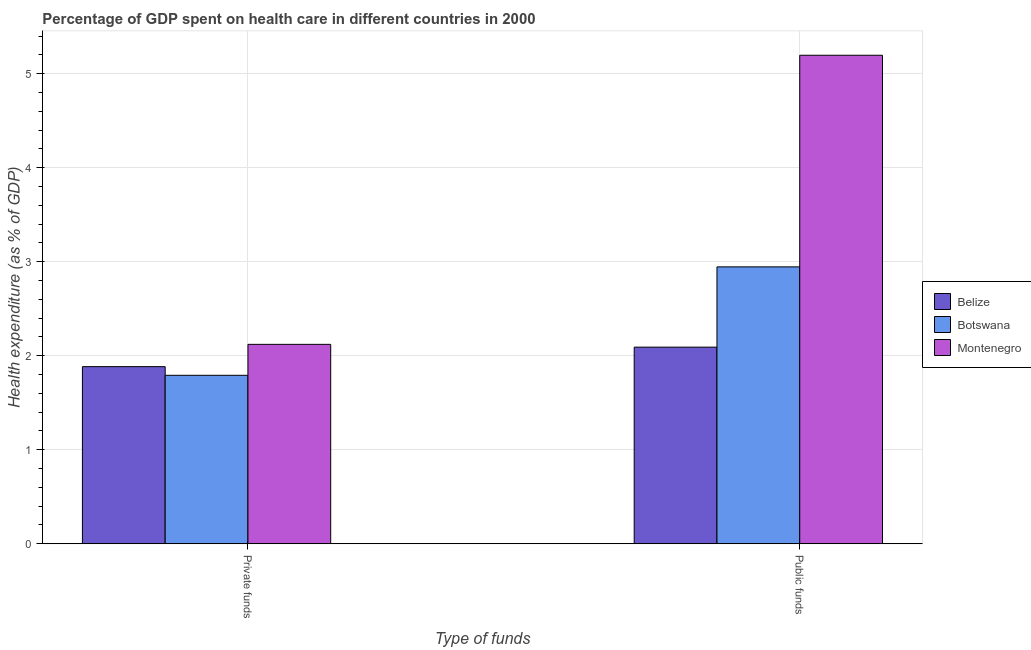How many groups of bars are there?
Provide a succinct answer. 2. Are the number of bars per tick equal to the number of legend labels?
Your answer should be compact. Yes. What is the label of the 1st group of bars from the left?
Make the answer very short. Private funds. What is the amount of private funds spent in healthcare in Botswana?
Make the answer very short. 1.79. Across all countries, what is the maximum amount of public funds spent in healthcare?
Offer a terse response. 5.2. Across all countries, what is the minimum amount of public funds spent in healthcare?
Make the answer very short. 2.09. In which country was the amount of public funds spent in healthcare maximum?
Your answer should be compact. Montenegro. In which country was the amount of private funds spent in healthcare minimum?
Provide a short and direct response. Botswana. What is the total amount of private funds spent in healthcare in the graph?
Provide a succinct answer. 5.8. What is the difference between the amount of public funds spent in healthcare in Montenegro and that in Botswana?
Offer a terse response. 2.25. What is the difference between the amount of private funds spent in healthcare in Botswana and the amount of public funds spent in healthcare in Montenegro?
Offer a very short reply. -3.4. What is the average amount of private funds spent in healthcare per country?
Keep it short and to the point. 1.93. What is the difference between the amount of public funds spent in healthcare and amount of private funds spent in healthcare in Montenegro?
Keep it short and to the point. 3.08. What is the ratio of the amount of public funds spent in healthcare in Belize to that in Montenegro?
Your response must be concise. 0.4. In how many countries, is the amount of public funds spent in healthcare greater than the average amount of public funds spent in healthcare taken over all countries?
Offer a terse response. 1. What does the 2nd bar from the left in Public funds represents?
Provide a short and direct response. Botswana. What does the 2nd bar from the right in Public funds represents?
Keep it short and to the point. Botswana. How many countries are there in the graph?
Offer a very short reply. 3. What is the difference between two consecutive major ticks on the Y-axis?
Make the answer very short. 1. Are the values on the major ticks of Y-axis written in scientific E-notation?
Give a very brief answer. No. What is the title of the graph?
Keep it short and to the point. Percentage of GDP spent on health care in different countries in 2000. What is the label or title of the X-axis?
Give a very brief answer. Type of funds. What is the label or title of the Y-axis?
Your answer should be very brief. Health expenditure (as % of GDP). What is the Health expenditure (as % of GDP) in Belize in Private funds?
Give a very brief answer. 1.88. What is the Health expenditure (as % of GDP) of Botswana in Private funds?
Keep it short and to the point. 1.79. What is the Health expenditure (as % of GDP) of Montenegro in Private funds?
Offer a terse response. 2.12. What is the Health expenditure (as % of GDP) of Belize in Public funds?
Give a very brief answer. 2.09. What is the Health expenditure (as % of GDP) of Botswana in Public funds?
Provide a short and direct response. 2.95. What is the Health expenditure (as % of GDP) of Montenegro in Public funds?
Your answer should be very brief. 5.2. Across all Type of funds, what is the maximum Health expenditure (as % of GDP) in Belize?
Your response must be concise. 2.09. Across all Type of funds, what is the maximum Health expenditure (as % of GDP) in Botswana?
Your answer should be compact. 2.95. Across all Type of funds, what is the maximum Health expenditure (as % of GDP) of Montenegro?
Offer a very short reply. 5.2. Across all Type of funds, what is the minimum Health expenditure (as % of GDP) in Belize?
Provide a succinct answer. 1.88. Across all Type of funds, what is the minimum Health expenditure (as % of GDP) in Botswana?
Your response must be concise. 1.79. Across all Type of funds, what is the minimum Health expenditure (as % of GDP) of Montenegro?
Make the answer very short. 2.12. What is the total Health expenditure (as % of GDP) of Belize in the graph?
Your response must be concise. 3.98. What is the total Health expenditure (as % of GDP) in Botswana in the graph?
Offer a terse response. 4.74. What is the total Health expenditure (as % of GDP) in Montenegro in the graph?
Offer a very short reply. 7.32. What is the difference between the Health expenditure (as % of GDP) of Belize in Private funds and that in Public funds?
Your answer should be very brief. -0.21. What is the difference between the Health expenditure (as % of GDP) of Botswana in Private funds and that in Public funds?
Offer a very short reply. -1.15. What is the difference between the Health expenditure (as % of GDP) in Montenegro in Private funds and that in Public funds?
Give a very brief answer. -3.08. What is the difference between the Health expenditure (as % of GDP) of Belize in Private funds and the Health expenditure (as % of GDP) of Botswana in Public funds?
Ensure brevity in your answer.  -1.06. What is the difference between the Health expenditure (as % of GDP) of Belize in Private funds and the Health expenditure (as % of GDP) of Montenegro in Public funds?
Keep it short and to the point. -3.31. What is the difference between the Health expenditure (as % of GDP) of Botswana in Private funds and the Health expenditure (as % of GDP) of Montenegro in Public funds?
Ensure brevity in your answer.  -3.4. What is the average Health expenditure (as % of GDP) of Belize per Type of funds?
Make the answer very short. 1.99. What is the average Health expenditure (as % of GDP) of Botswana per Type of funds?
Make the answer very short. 2.37. What is the average Health expenditure (as % of GDP) in Montenegro per Type of funds?
Provide a succinct answer. 3.66. What is the difference between the Health expenditure (as % of GDP) of Belize and Health expenditure (as % of GDP) of Botswana in Private funds?
Offer a very short reply. 0.09. What is the difference between the Health expenditure (as % of GDP) in Belize and Health expenditure (as % of GDP) in Montenegro in Private funds?
Offer a terse response. -0.24. What is the difference between the Health expenditure (as % of GDP) in Botswana and Health expenditure (as % of GDP) in Montenegro in Private funds?
Offer a terse response. -0.33. What is the difference between the Health expenditure (as % of GDP) in Belize and Health expenditure (as % of GDP) in Botswana in Public funds?
Your answer should be very brief. -0.85. What is the difference between the Health expenditure (as % of GDP) of Belize and Health expenditure (as % of GDP) of Montenegro in Public funds?
Offer a very short reply. -3.1. What is the difference between the Health expenditure (as % of GDP) of Botswana and Health expenditure (as % of GDP) of Montenegro in Public funds?
Provide a short and direct response. -2.25. What is the ratio of the Health expenditure (as % of GDP) in Belize in Private funds to that in Public funds?
Ensure brevity in your answer.  0.9. What is the ratio of the Health expenditure (as % of GDP) of Botswana in Private funds to that in Public funds?
Give a very brief answer. 0.61. What is the ratio of the Health expenditure (as % of GDP) of Montenegro in Private funds to that in Public funds?
Offer a very short reply. 0.41. What is the difference between the highest and the second highest Health expenditure (as % of GDP) of Belize?
Your answer should be compact. 0.21. What is the difference between the highest and the second highest Health expenditure (as % of GDP) of Botswana?
Your answer should be very brief. 1.15. What is the difference between the highest and the second highest Health expenditure (as % of GDP) of Montenegro?
Give a very brief answer. 3.08. What is the difference between the highest and the lowest Health expenditure (as % of GDP) of Belize?
Provide a short and direct response. 0.21. What is the difference between the highest and the lowest Health expenditure (as % of GDP) of Botswana?
Provide a short and direct response. 1.15. What is the difference between the highest and the lowest Health expenditure (as % of GDP) in Montenegro?
Ensure brevity in your answer.  3.08. 